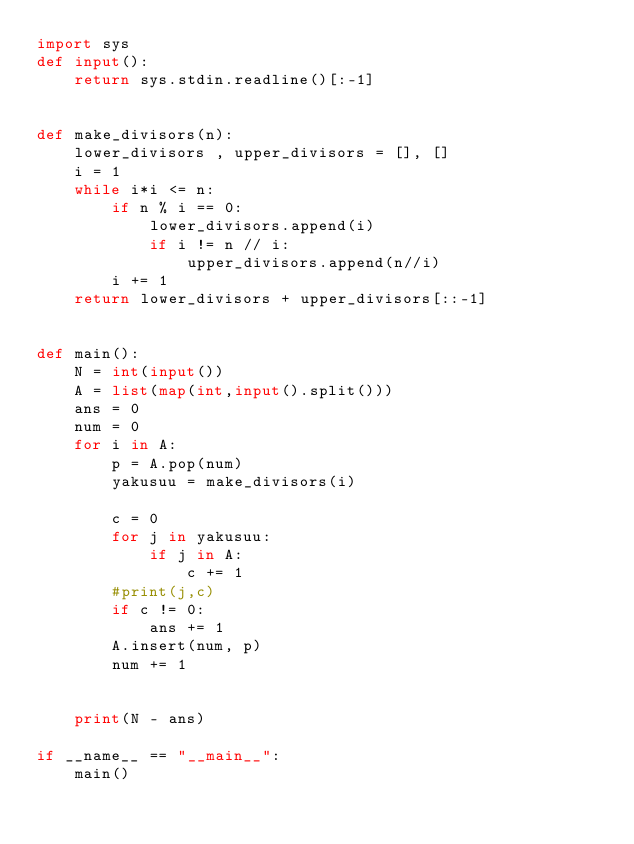Convert code to text. <code><loc_0><loc_0><loc_500><loc_500><_Python_>import sys
def input():
    return sys.stdin.readline()[:-1]


def make_divisors(n):
    lower_divisors , upper_divisors = [], []
    i = 1
    while i*i <= n:
        if n % i == 0:
            lower_divisors.append(i)
            if i != n // i:
                upper_divisors.append(n//i)
        i += 1
    return lower_divisors + upper_divisors[::-1]


def main():
    N = int(input())
    A = list(map(int,input().split()))
    ans = 0
    num = 0
    for i in A:
        p = A.pop(num)
        yakusuu = make_divisors(i)

        c = 0
        for j in yakusuu:
            if j in A:
                c += 1
        #print(j,c)
        if c != 0:
            ans += 1
        A.insert(num, p)
        num += 1


    print(N - ans)

if __name__ == "__main__":
    main()</code> 